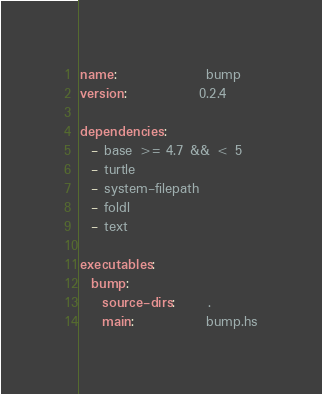<code> <loc_0><loc_0><loc_500><loc_500><_YAML_>name:                bump
version:             0.2.4

dependencies:
  - base >= 4.7 && < 5
  - turtle
  - system-filepath
  - foldl
  - text

executables:
  bump:
    source-dirs:      .
    main:             bump.hs
</code> 